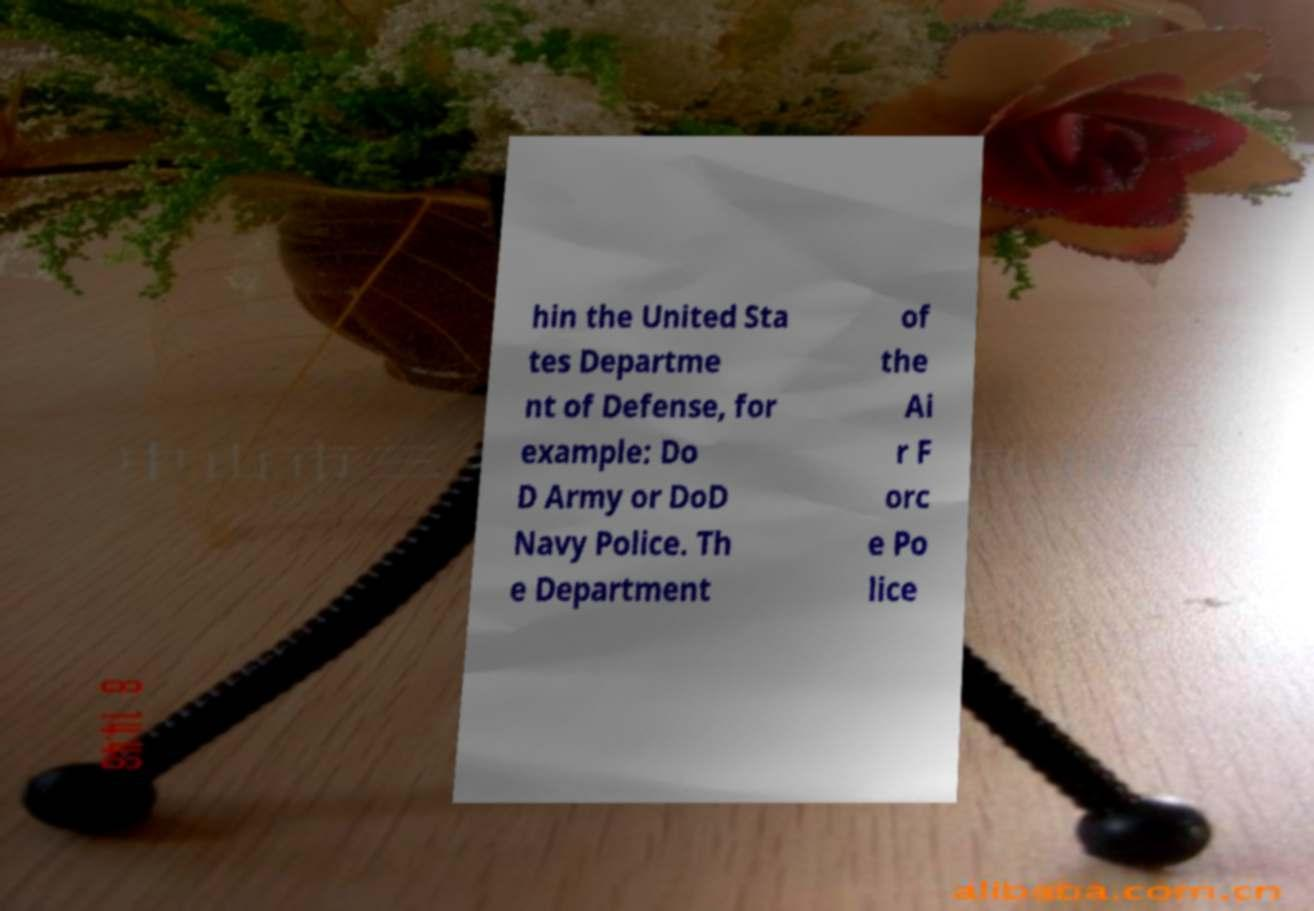I need the written content from this picture converted into text. Can you do that? hin the United Sta tes Departme nt of Defense, for example: Do D Army or DoD Navy Police. Th e Department of the Ai r F orc e Po lice 